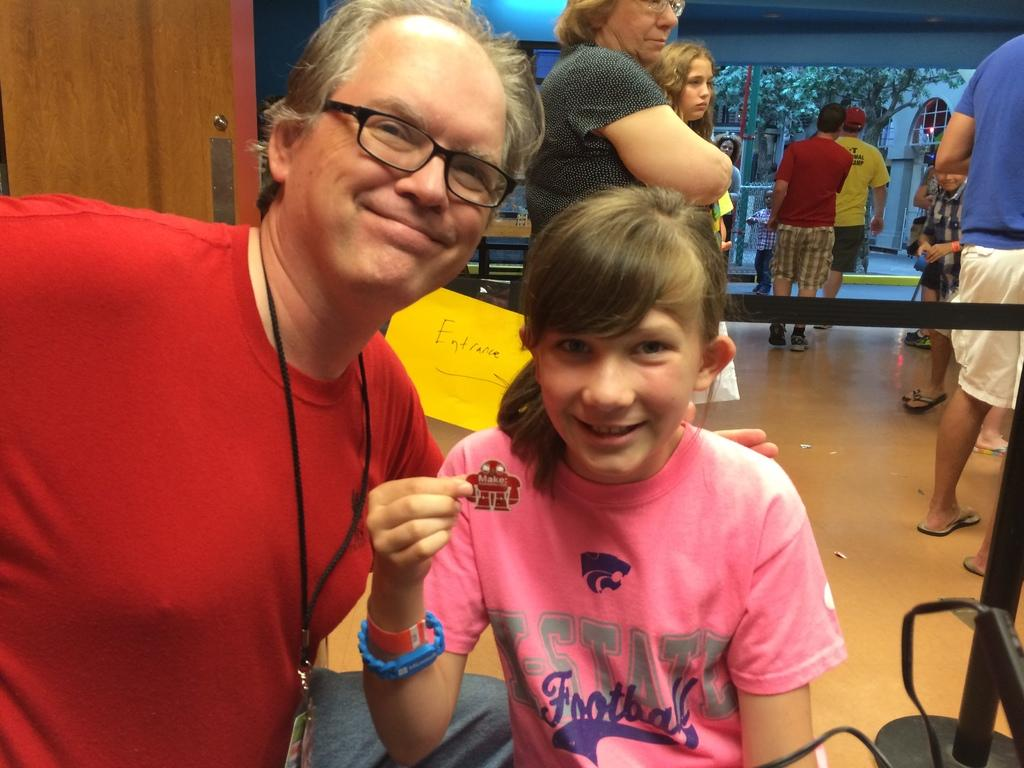What is happening in the room in the image? There are people standing in the room, including a man with an ID card and a girl. Can you describe the man in the room? The man in the room is wearing spectacles. What is the girl doing in the room? The provided facts do not specify what the girl is doing in the room. What can be seen outside the room in the image? Trees are visible in the image. What type of bubble is floating in the room in the image? There is no bubble present in the image. Is there a plane visible in the room in the image? There is no plane visible in the room in the image. 